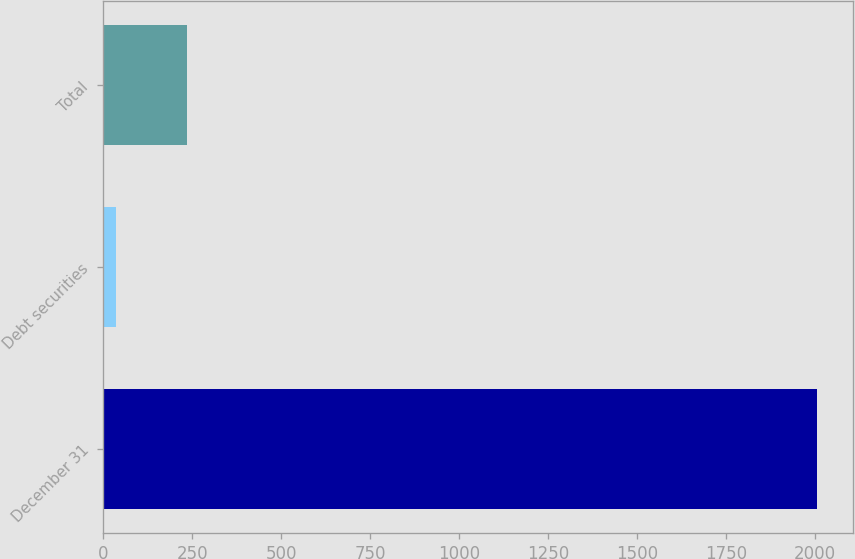Convert chart. <chart><loc_0><loc_0><loc_500><loc_500><bar_chart><fcel>December 31<fcel>Debt securities<fcel>Total<nl><fcel>2005<fcel>37.1<fcel>233.89<nl></chart> 